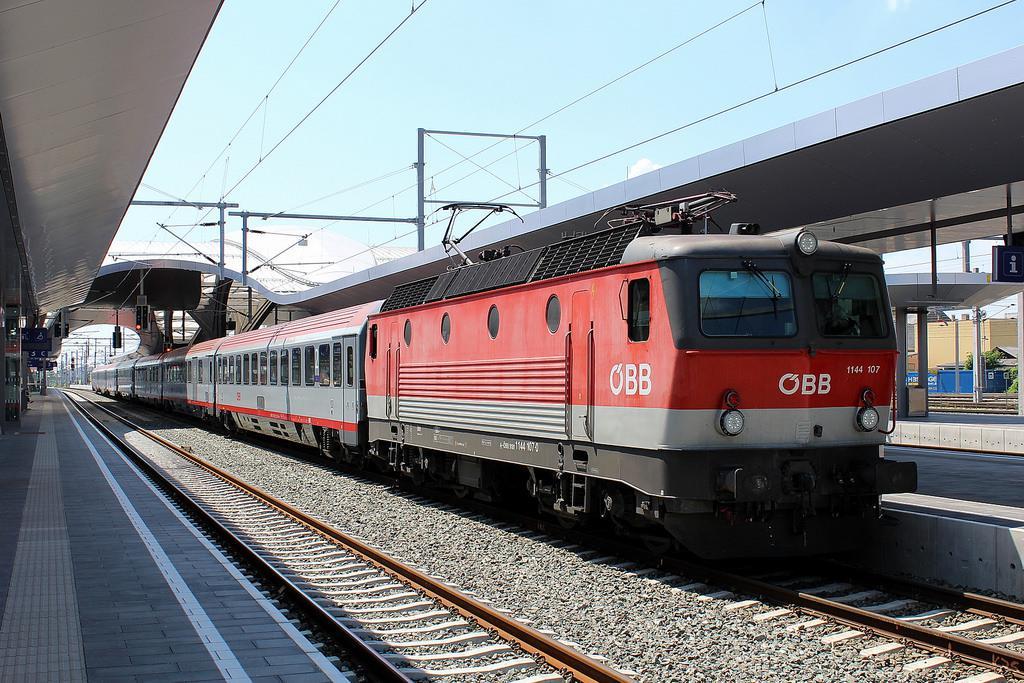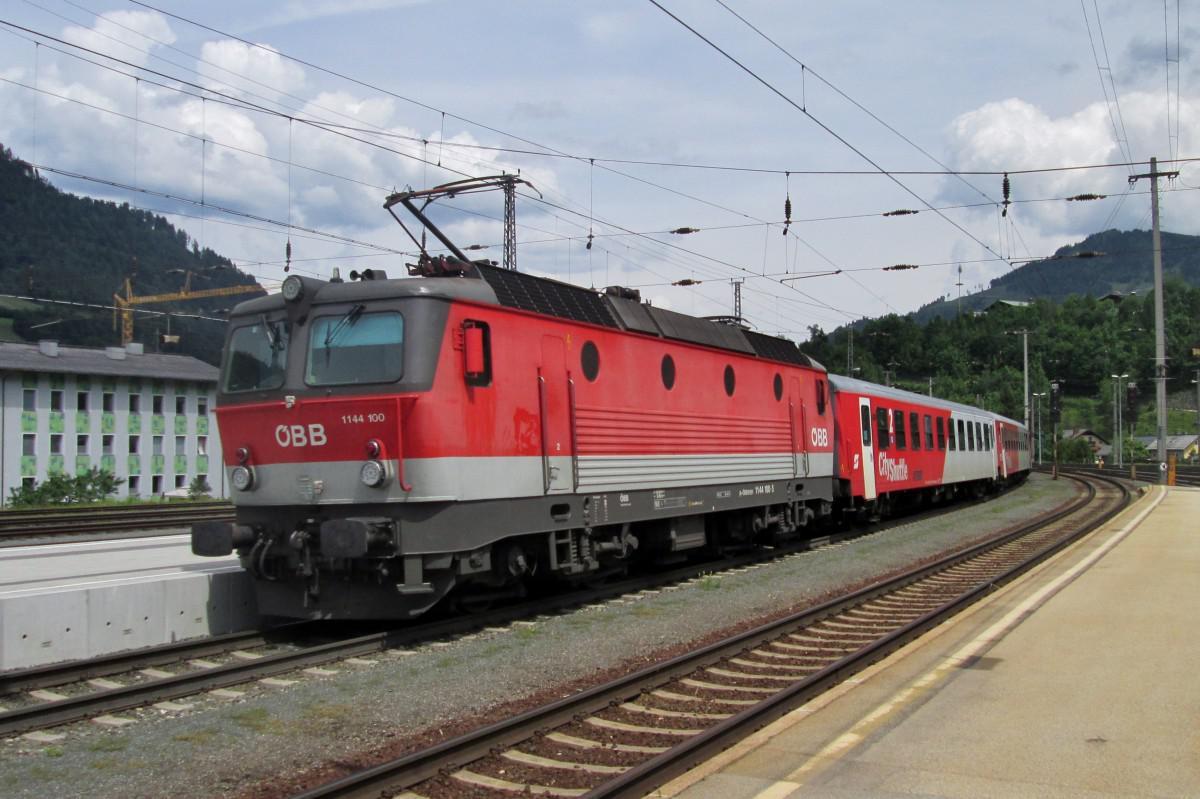The first image is the image on the left, the second image is the image on the right. Considering the images on both sides, is "Both trains are pointed in the same direction." valid? Answer yes or no. No. The first image is the image on the left, the second image is the image on the right. For the images displayed, is the sentence "One image shows a leftward headed train, and the other shows a rightward angled train." factually correct? Answer yes or no. Yes. 